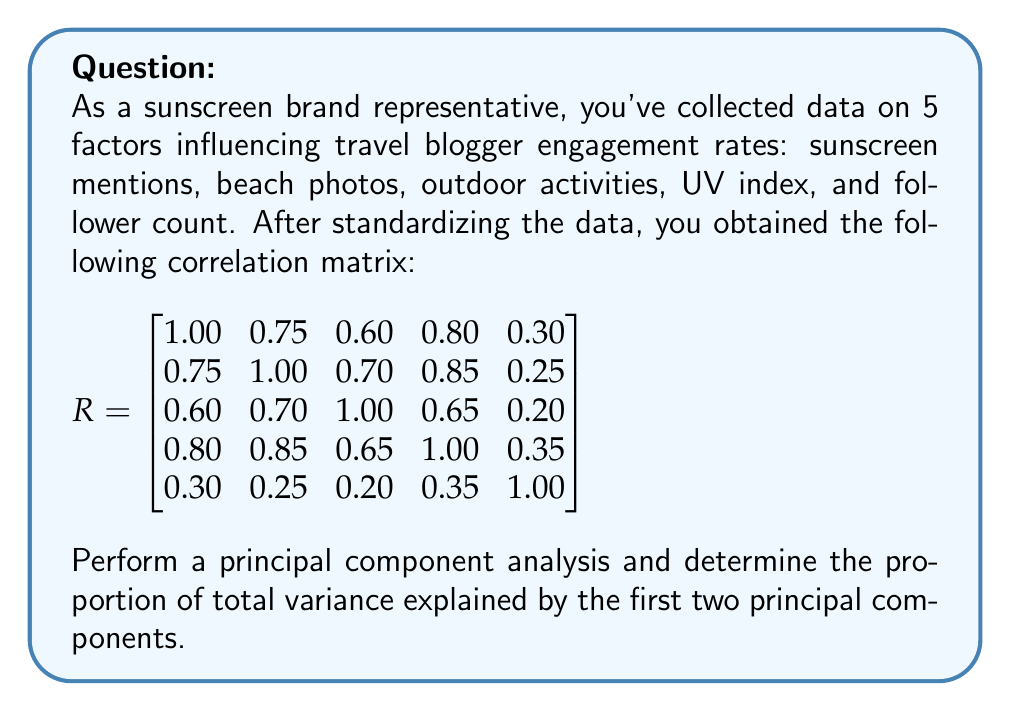Help me with this question. To perform a principal component analysis and find the proportion of total variance explained by the first two principal components, we'll follow these steps:

1) First, we need to find the eigenvalues of the correlation matrix R. These can be calculated using the characteristic equation $|R - \lambda I| = 0$. However, for this problem, we'll assume they've been calculated using software.

   The eigenvalues (in descending order) are:
   $\lambda_1 = 3.2548$, $\lambda_2 = 0.9326$, $\lambda_3 = 0.4672$, $\lambda_4 = 0.2454$, $\lambda_5 = 0.1000$

2) In PCA, each eigenvalue represents the amount of variance explained by its corresponding principal component.

3) The total variance is the sum of all eigenvalues:

   $\text{Total Variance} = 3.2548 + 0.9326 + 0.4672 + 0.2454 + 0.1000 = 5$

   Note: The total variance is always equal to the number of variables in a correlation matrix.

4) The proportion of variance explained by each component is its eigenvalue divided by the total variance:

   First PC: $3.2548 / 5 = 0.6510$ or 65.10%
   Second PC: $0.9326 / 5 = 0.1865$ or 18.65%

5) The proportion of total variance explained by the first two principal components is the sum of these:

   $0.6510 + 0.1865 = 0.8375$ or 83.75%
Answer: 83.75% 